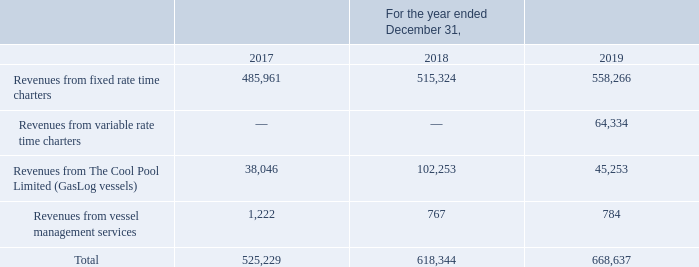GasLog Ltd. and its Subsidiaries
Notes to the consolidated financial statements (Continued)
For the years ended December 31, 2017, 2018 and 2019
(All amounts expressed in thousands of U.S. Dollars, except share and per share data)
18. Revenues from Contracts with Customers
The Group has recognized the following amounts relating to revenues:
Revenues from The Cool Pool Limited relate only to the pool revenues received from GasLog’s vessels operating in the Cool Pool and do not include the Net pool allocation to GasLog of ($4,264) for the year ended December 31, 2019 ($17,818 for the year ended December 31, 2018 and $7,254 for the year ended December 31, 2017), which is recorded as a separate line item in the Profit or Loss Statement.
Following the exit from the Cool Pool, management allocates revenues from time charters to two categories: (a) variable rate charters and (b) fixed rate charters. The variable rate charter category contains vessels operating in the LNG carrier spot and short-term market or those which have a variable rate of hire across the charter period.
What are the components of the revenues? Revenues from fixed rate time charters, revenues from variable rate time charters, revenues from the cool pool limited (gaslog vessels), revenues from vessel management services. What are the two segments the management allocated the revenues from time charters? (a) variable rate charters and (b) fixed rate charters. What does the revenues from The Cool Pool Limited represent? Revenues from the cool pool limited relate only to the pool revenues received from gaslog’s vessels operating in the cool pool. In which year was the revenues from fixed rate time charters the highest? 558,266 > 515,324 > 485,961
Answer: 2019. What was the change in revenues from The Cool Pool Limited  from 2017 to 2018?
Answer scale should be: thousand. 102,253 - 38,046 
Answer: 64207. What was the percentage change in total revenue from 2018 to 2019?
Answer scale should be: percent. (668,637 - 618,344)/618,344 
Answer: 8.13. 